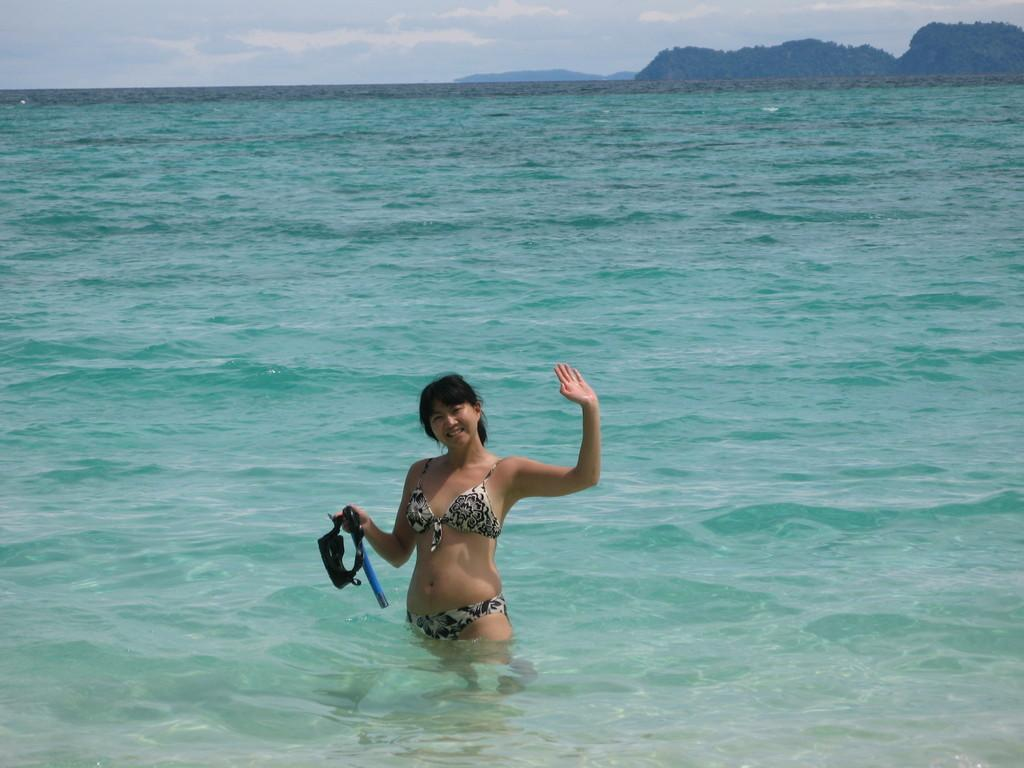Who is present in the image? There is a woman in the image. What is the woman holding in the image? The woman is holding an object. Where is the woman located in the image? The woman is standing in the water. What can be seen in the distance in the image? There are hills visible in the image. What is visible in the background of the image? The sky is visible in the background of the image. Can you see a volcano erupting in the image? There is no volcano present in the image, and therefore no eruption can be observed. What type of muscle is the woman exercising in the image? There is no indication of the woman exercising or using any muscles in the image. 